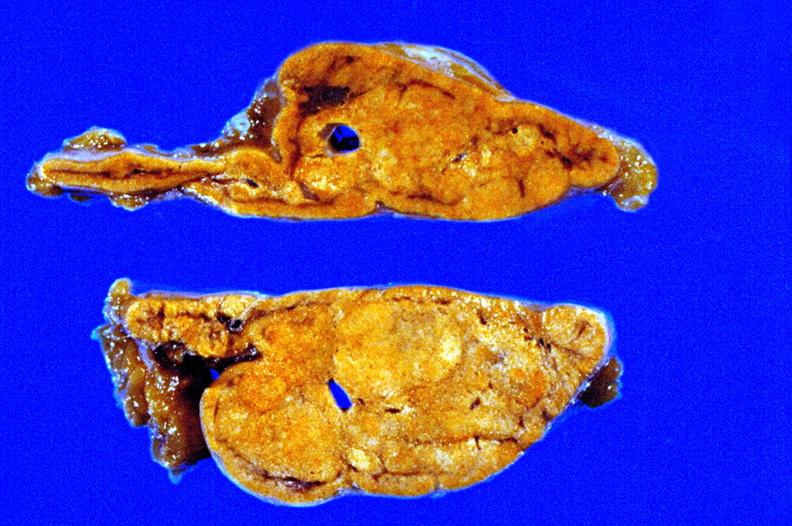s nodules present?
Answer the question using a single word or phrase. Yes 